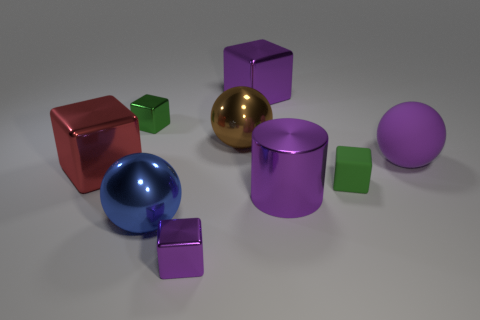What materials are the objects in the image made of? The objects appear to be made of various materials with different finishes, such as matte and reflective surfaces, possibly indicating materials like plastic, rubber, or metal. 